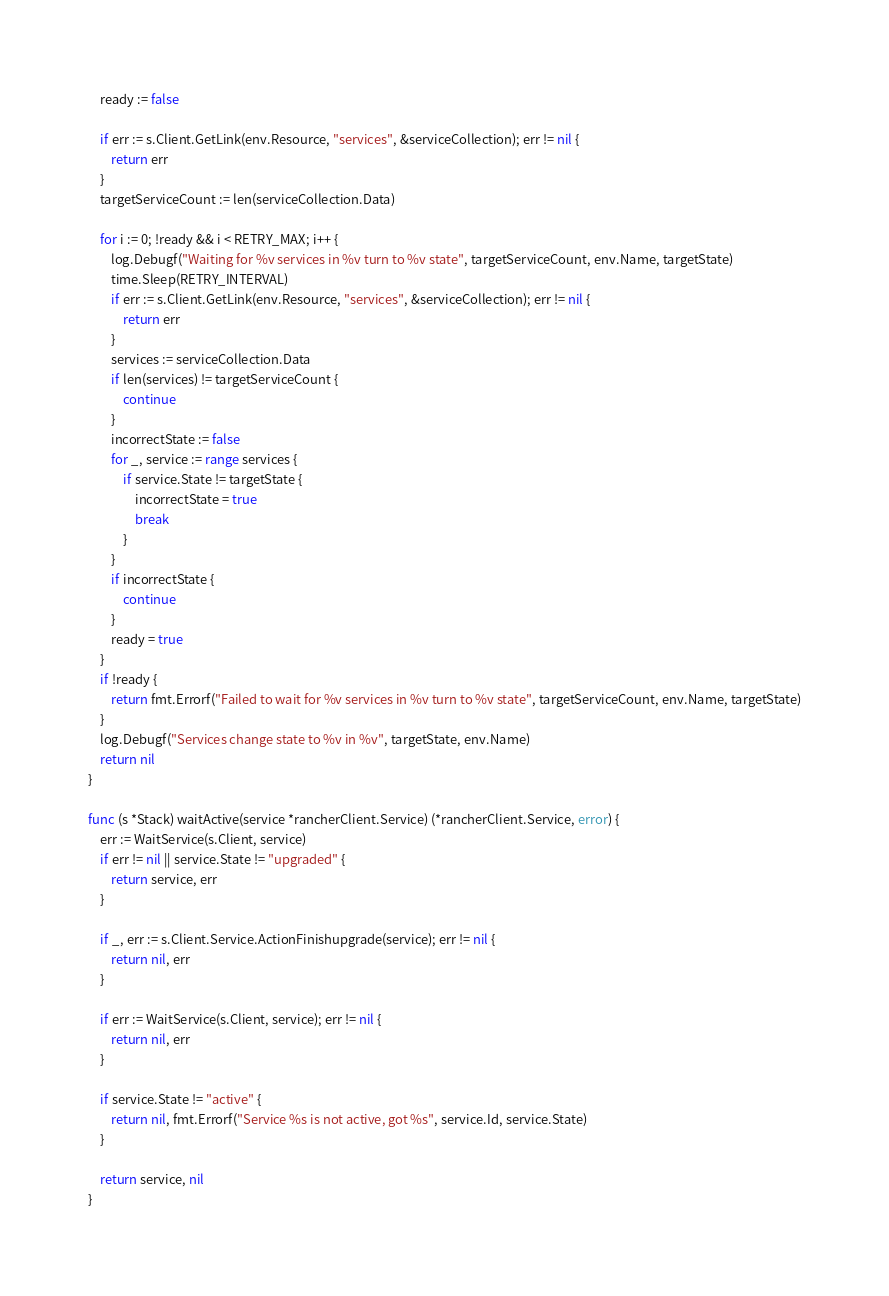Convert code to text. <code><loc_0><loc_0><loc_500><loc_500><_Go_>	ready := false

	if err := s.Client.GetLink(env.Resource, "services", &serviceCollection); err != nil {
		return err
	}
	targetServiceCount := len(serviceCollection.Data)

	for i := 0; !ready && i < RETRY_MAX; i++ {
		log.Debugf("Waiting for %v services in %v turn to %v state", targetServiceCount, env.Name, targetState)
		time.Sleep(RETRY_INTERVAL)
		if err := s.Client.GetLink(env.Resource, "services", &serviceCollection); err != nil {
			return err
		}
		services := serviceCollection.Data
		if len(services) != targetServiceCount {
			continue
		}
		incorrectState := false
		for _, service := range services {
			if service.State != targetState {
				incorrectState = true
				break
			}
		}
		if incorrectState {
			continue
		}
		ready = true
	}
	if !ready {
		return fmt.Errorf("Failed to wait for %v services in %v turn to %v state", targetServiceCount, env.Name, targetState)
	}
	log.Debugf("Services change state to %v in %v", targetState, env.Name)
	return nil
}

func (s *Stack) waitActive(service *rancherClient.Service) (*rancherClient.Service, error) {
	err := WaitService(s.Client, service)
	if err != nil || service.State != "upgraded" {
		return service, err
	}

	if _, err := s.Client.Service.ActionFinishupgrade(service); err != nil {
		return nil, err
	}

	if err := WaitService(s.Client, service); err != nil {
		return nil, err
	}

	if service.State != "active" {
		return nil, fmt.Errorf("Service %s is not active, got %s", service.Id, service.State)
	}

	return service, nil
}
</code> 